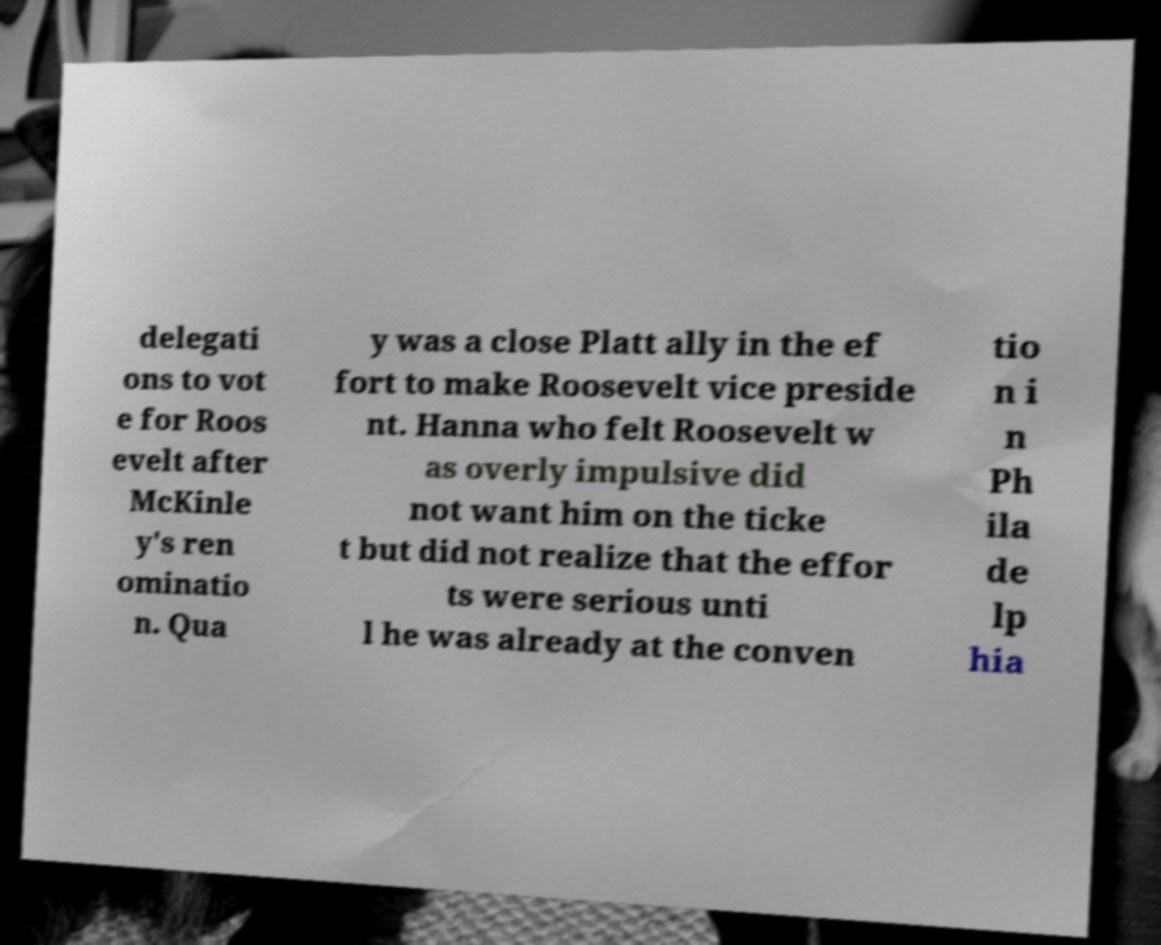I need the written content from this picture converted into text. Can you do that? delegati ons to vot e for Roos evelt after McKinle y's ren ominatio n. Qua y was a close Platt ally in the ef fort to make Roosevelt vice preside nt. Hanna who felt Roosevelt w as overly impulsive did not want him on the ticke t but did not realize that the effor ts were serious unti l he was already at the conven tio n i n Ph ila de lp hia 